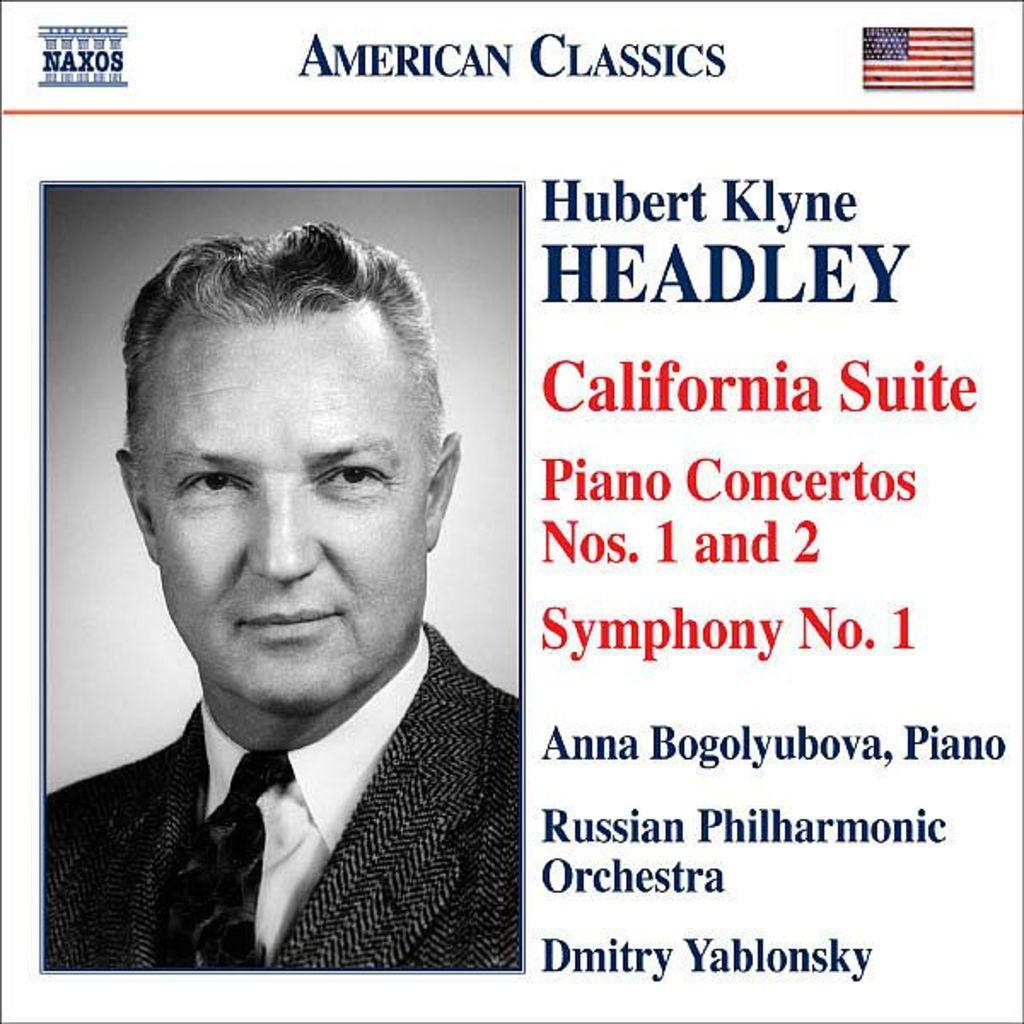What is the main subject of the image? The main subject of the image is a man. What is the man wearing in the image? The man is wearing a suit in the image. What type of force is being exerted by the man in the image? There is no indication of any force being exerted by the man in the image. Can you see a club or any sports equipment in the image? No, there is no club or sports equipment visible in the image. 